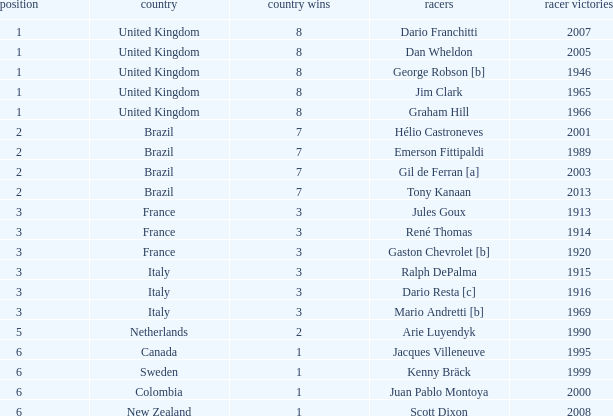What is the average number of wins of drivers from Sweden? 1999.0. 